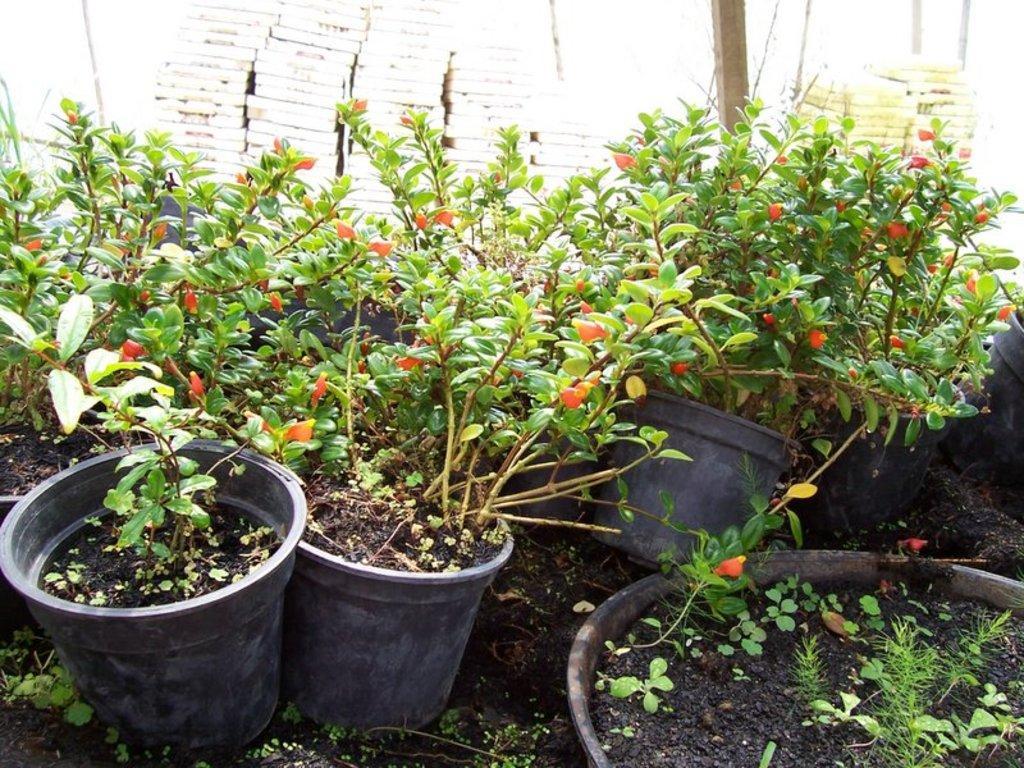Can you describe this image briefly? We can see house plants and buds. 